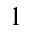Convert formula to latex. <formula><loc_0><loc_0><loc_500><loc_500>1</formula> 